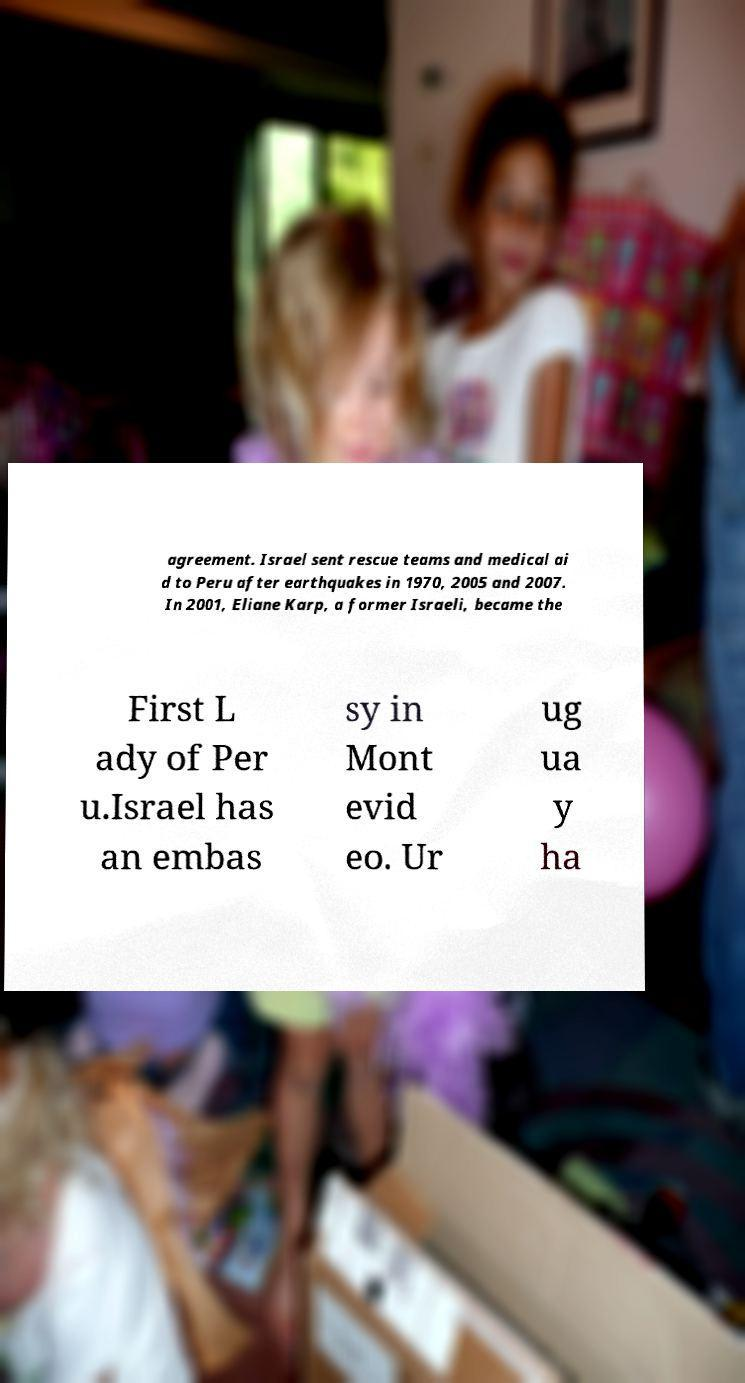There's text embedded in this image that I need extracted. Can you transcribe it verbatim? agreement. Israel sent rescue teams and medical ai d to Peru after earthquakes in 1970, 2005 and 2007. In 2001, Eliane Karp, a former Israeli, became the First L ady of Per u.Israel has an embas sy in Mont evid eo. Ur ug ua y ha 